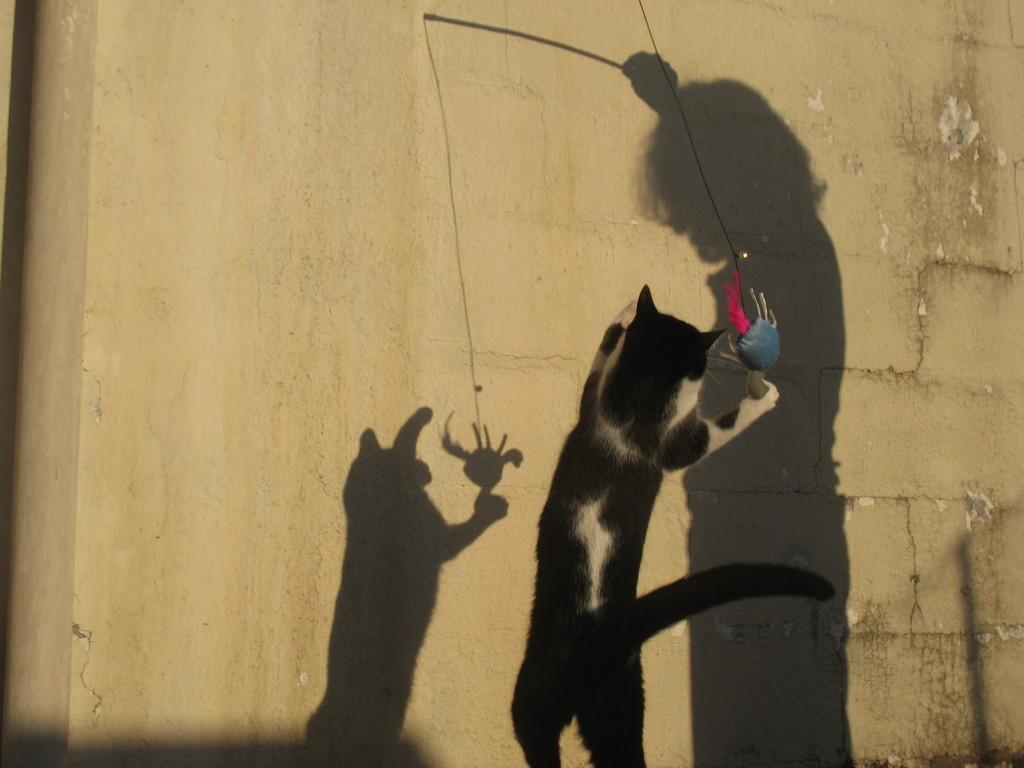Please provide a concise description of this image. In this image, we can see a cat and we can see the shadows of a person and a cat on the wall. 